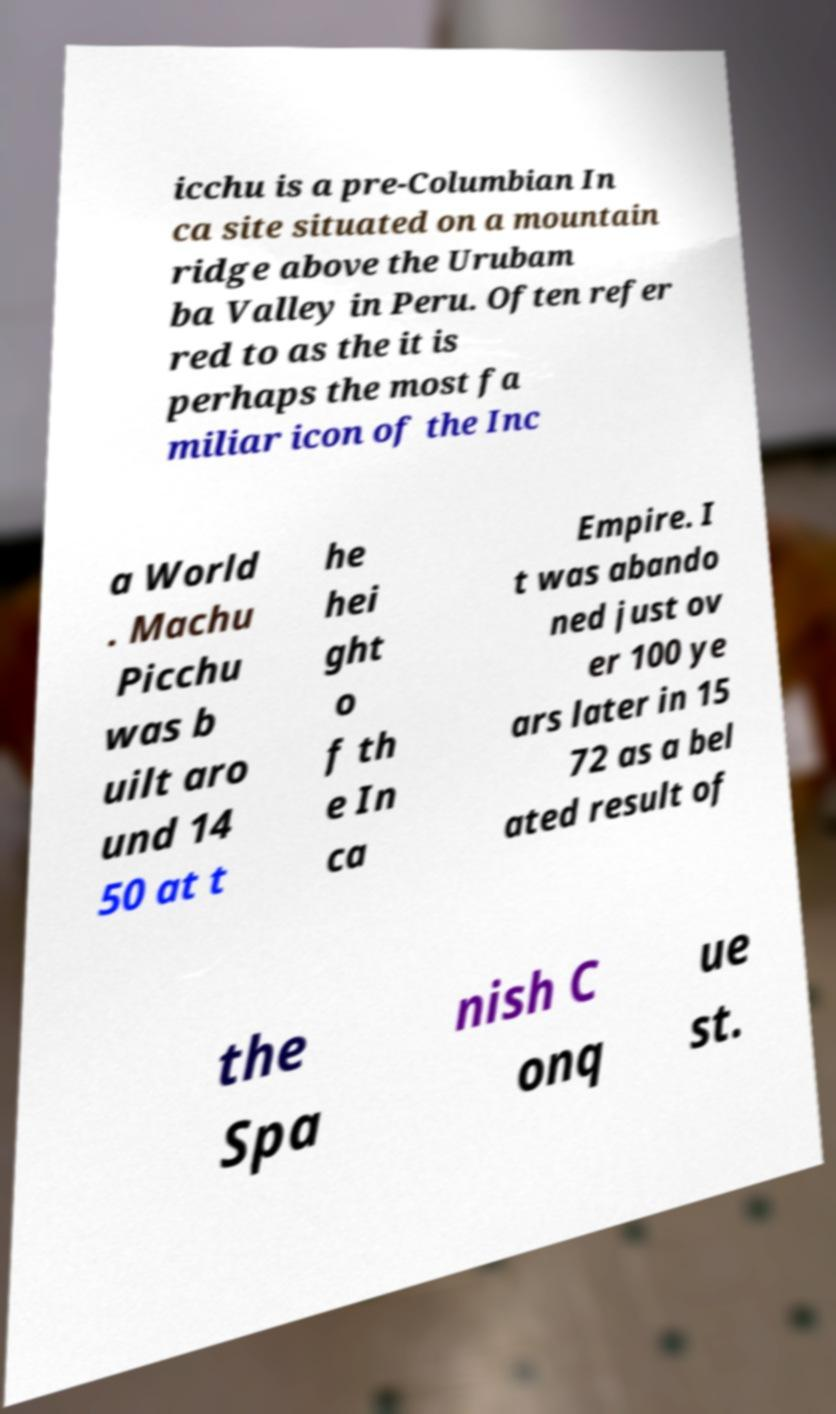Can you read and provide the text displayed in the image?This photo seems to have some interesting text. Can you extract and type it out for me? icchu is a pre-Columbian In ca site situated on a mountain ridge above the Urubam ba Valley in Peru. Often refer red to as the it is perhaps the most fa miliar icon of the Inc a World . Machu Picchu was b uilt aro und 14 50 at t he hei ght o f th e In ca Empire. I t was abando ned just ov er 100 ye ars later in 15 72 as a bel ated result of the Spa nish C onq ue st. 